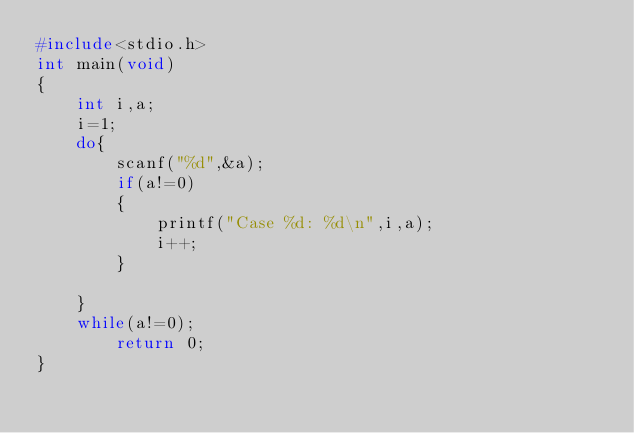Convert code to text. <code><loc_0><loc_0><loc_500><loc_500><_C_>#include<stdio.h>
int main(void)
{
    int i,a;
    i=1;
    do{
        scanf("%d",&a);
        if(a!=0)
        {
            printf("Case %d: %d\n",i,a);
            i++;
        }
        
    }
    while(a!=0);
        return 0;
}</code> 